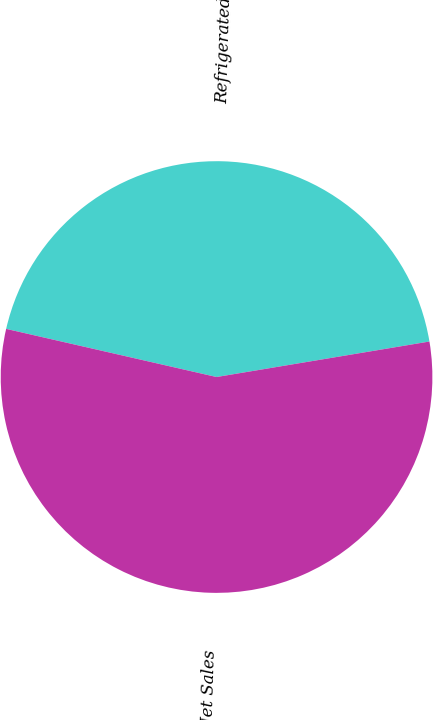Convert chart to OTSL. <chart><loc_0><loc_0><loc_500><loc_500><pie_chart><fcel>Refrigerated Foods<fcel>Total Net Sales<nl><fcel>43.79%<fcel>56.21%<nl></chart> 